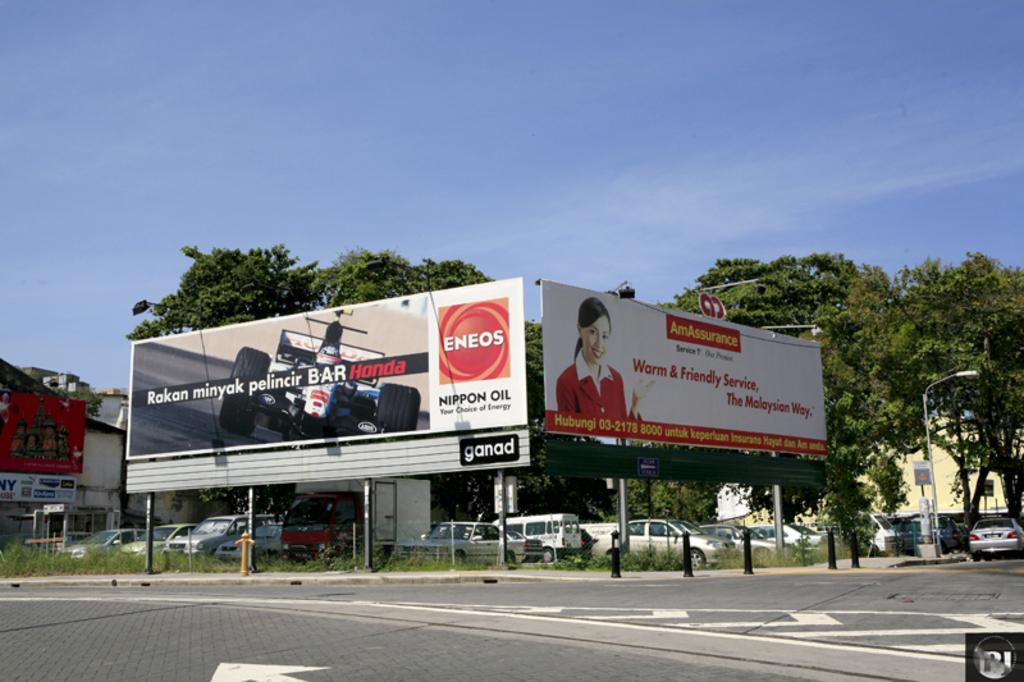<image>
Describe the image concisely. Two perpendicular billboards on a corner of the street shows a Honda and AmAssurance advertisements. 